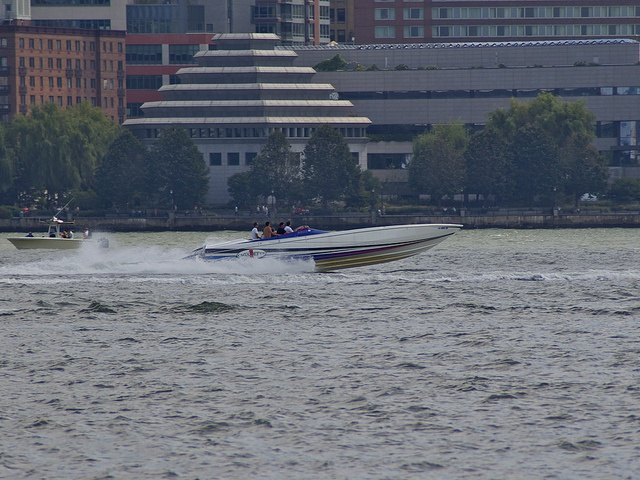Describe the objects in this image and their specific colors. I can see boat in gray, darkgray, black, and navy tones, boat in gray, darkgray, and black tones, people in gray, maroon, black, brown, and navy tones, people in gray, black, and darkgray tones, and people in gray, black, and darkgray tones in this image. 